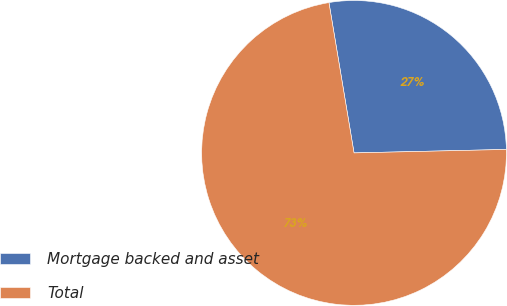<chart> <loc_0><loc_0><loc_500><loc_500><pie_chart><fcel>Mortgage backed and asset<fcel>Total<nl><fcel>27.27%<fcel>72.73%<nl></chart> 